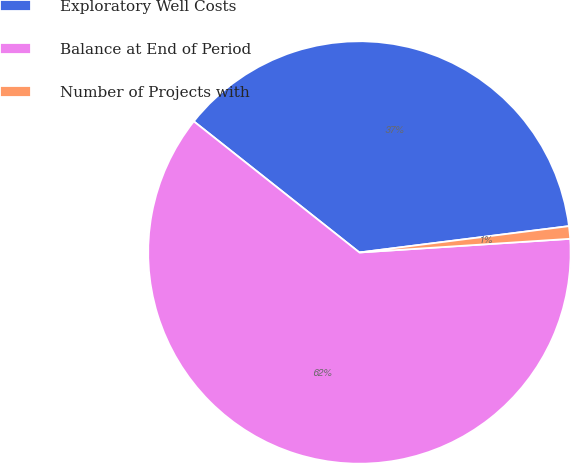Convert chart to OTSL. <chart><loc_0><loc_0><loc_500><loc_500><pie_chart><fcel>Exploratory Well Costs<fcel>Balance at End of Period<fcel>Number of Projects with<nl><fcel>37.35%<fcel>61.69%<fcel>0.96%<nl></chart> 